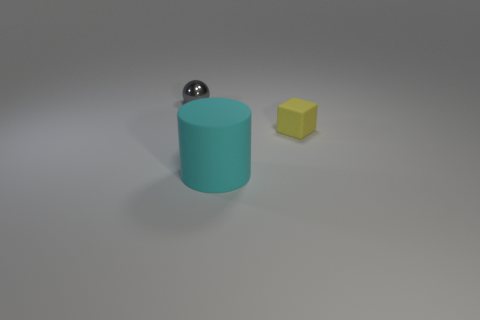How many objects have the same material as the big cylinder?
Give a very brief answer. 1. How many things are either green metal balls or things that are behind the cyan cylinder?
Make the answer very short. 2. Are the thing in front of the tiny yellow rubber cube and the tiny yellow object made of the same material?
Keep it short and to the point. Yes. There is a rubber block that is the same size as the gray thing; what is its color?
Your answer should be very brief. Yellow. Is there a cyan matte object of the same shape as the metallic thing?
Your answer should be very brief. No. There is a tiny object right of the tiny object that is on the left side of the yellow rubber thing behind the big cyan matte cylinder; what is its color?
Provide a short and direct response. Yellow. How many matte objects are either cyan objects or spheres?
Make the answer very short. 1. Is the number of small metal things to the right of the rubber cylinder greater than the number of gray metal objects in front of the gray shiny sphere?
Your answer should be compact. No. What number of other things are there of the same size as the gray shiny object?
Keep it short and to the point. 1. There is a rubber thing in front of the small object that is in front of the small shiny ball; what size is it?
Ensure brevity in your answer.  Large. 